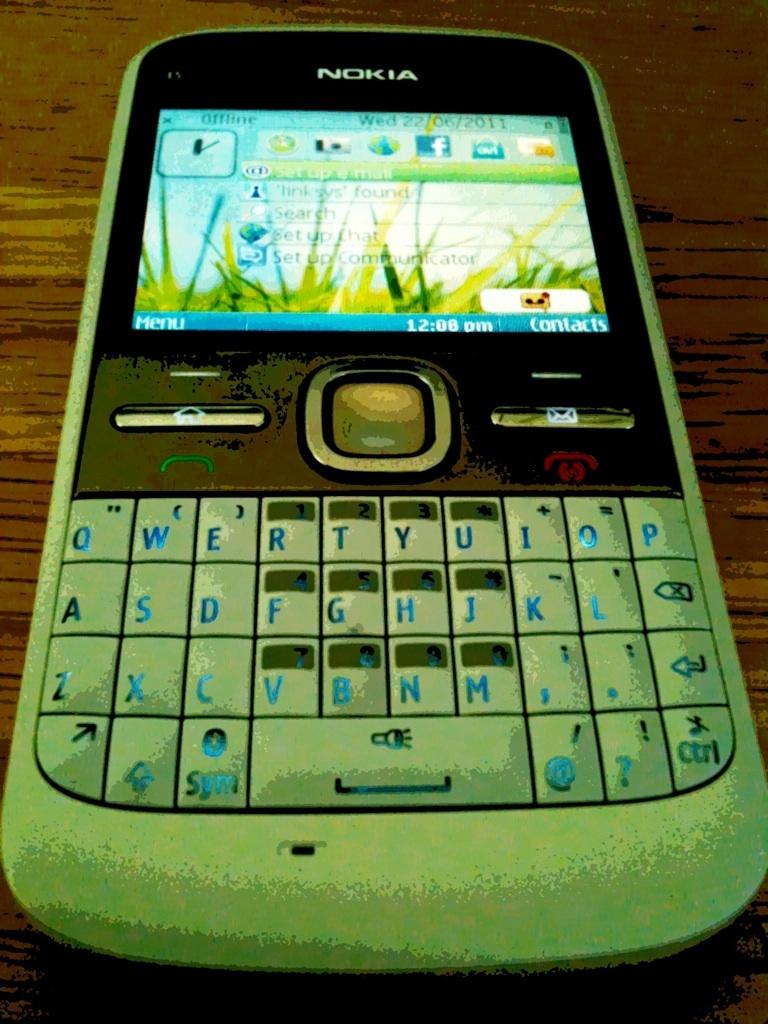What is the brand of the mobile?
Keep it short and to the point. Nokia. What time is on the phone?
Offer a terse response. 12:08 pm. 